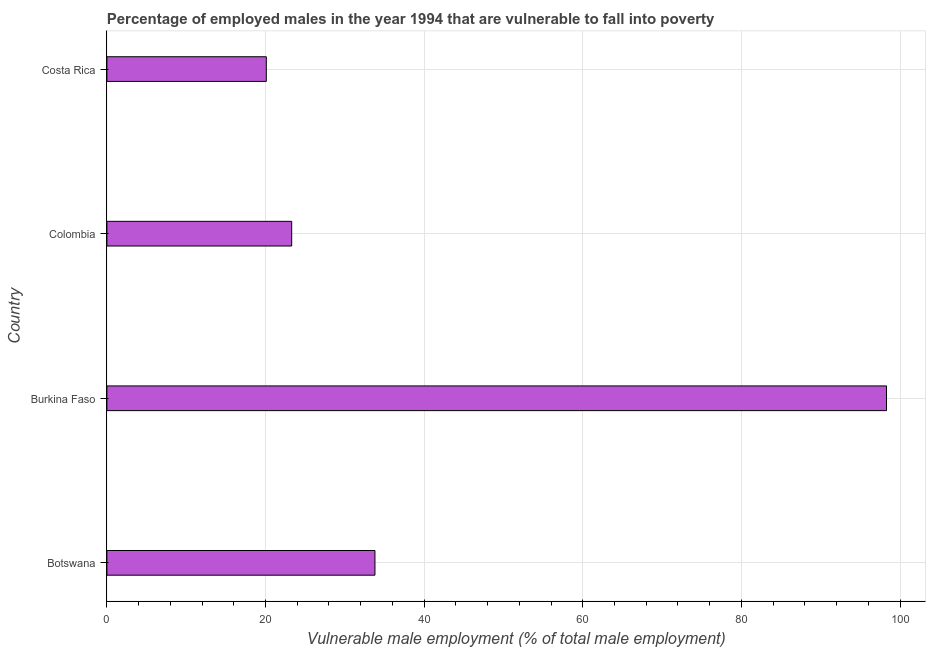Does the graph contain any zero values?
Provide a short and direct response. No. Does the graph contain grids?
Offer a very short reply. Yes. What is the title of the graph?
Offer a very short reply. Percentage of employed males in the year 1994 that are vulnerable to fall into poverty. What is the label or title of the X-axis?
Offer a very short reply. Vulnerable male employment (% of total male employment). What is the label or title of the Y-axis?
Keep it short and to the point. Country. What is the percentage of employed males who are vulnerable to fall into poverty in Burkina Faso?
Your answer should be very brief. 98.3. Across all countries, what is the maximum percentage of employed males who are vulnerable to fall into poverty?
Keep it short and to the point. 98.3. Across all countries, what is the minimum percentage of employed males who are vulnerable to fall into poverty?
Make the answer very short. 20.1. In which country was the percentage of employed males who are vulnerable to fall into poverty maximum?
Provide a short and direct response. Burkina Faso. In which country was the percentage of employed males who are vulnerable to fall into poverty minimum?
Keep it short and to the point. Costa Rica. What is the sum of the percentage of employed males who are vulnerable to fall into poverty?
Give a very brief answer. 175.5. What is the difference between the percentage of employed males who are vulnerable to fall into poverty in Botswana and Colombia?
Provide a succinct answer. 10.5. What is the average percentage of employed males who are vulnerable to fall into poverty per country?
Ensure brevity in your answer.  43.88. What is the median percentage of employed males who are vulnerable to fall into poverty?
Your answer should be compact. 28.55. What is the ratio of the percentage of employed males who are vulnerable to fall into poverty in Colombia to that in Costa Rica?
Provide a succinct answer. 1.16. Is the percentage of employed males who are vulnerable to fall into poverty in Burkina Faso less than that in Costa Rica?
Provide a succinct answer. No. Is the difference between the percentage of employed males who are vulnerable to fall into poverty in Botswana and Colombia greater than the difference between any two countries?
Offer a very short reply. No. What is the difference between the highest and the second highest percentage of employed males who are vulnerable to fall into poverty?
Ensure brevity in your answer.  64.5. What is the difference between the highest and the lowest percentage of employed males who are vulnerable to fall into poverty?
Make the answer very short. 78.2. In how many countries, is the percentage of employed males who are vulnerable to fall into poverty greater than the average percentage of employed males who are vulnerable to fall into poverty taken over all countries?
Provide a succinct answer. 1. Are all the bars in the graph horizontal?
Provide a short and direct response. Yes. How many countries are there in the graph?
Your answer should be very brief. 4. What is the difference between two consecutive major ticks on the X-axis?
Give a very brief answer. 20. What is the Vulnerable male employment (% of total male employment) in Botswana?
Your answer should be very brief. 33.8. What is the Vulnerable male employment (% of total male employment) in Burkina Faso?
Keep it short and to the point. 98.3. What is the Vulnerable male employment (% of total male employment) in Colombia?
Provide a succinct answer. 23.3. What is the Vulnerable male employment (% of total male employment) of Costa Rica?
Your answer should be very brief. 20.1. What is the difference between the Vulnerable male employment (% of total male employment) in Botswana and Burkina Faso?
Give a very brief answer. -64.5. What is the difference between the Vulnerable male employment (% of total male employment) in Burkina Faso and Costa Rica?
Give a very brief answer. 78.2. What is the difference between the Vulnerable male employment (% of total male employment) in Colombia and Costa Rica?
Provide a short and direct response. 3.2. What is the ratio of the Vulnerable male employment (% of total male employment) in Botswana to that in Burkina Faso?
Offer a terse response. 0.34. What is the ratio of the Vulnerable male employment (% of total male employment) in Botswana to that in Colombia?
Your answer should be compact. 1.45. What is the ratio of the Vulnerable male employment (% of total male employment) in Botswana to that in Costa Rica?
Provide a short and direct response. 1.68. What is the ratio of the Vulnerable male employment (% of total male employment) in Burkina Faso to that in Colombia?
Give a very brief answer. 4.22. What is the ratio of the Vulnerable male employment (% of total male employment) in Burkina Faso to that in Costa Rica?
Offer a terse response. 4.89. What is the ratio of the Vulnerable male employment (% of total male employment) in Colombia to that in Costa Rica?
Keep it short and to the point. 1.16. 